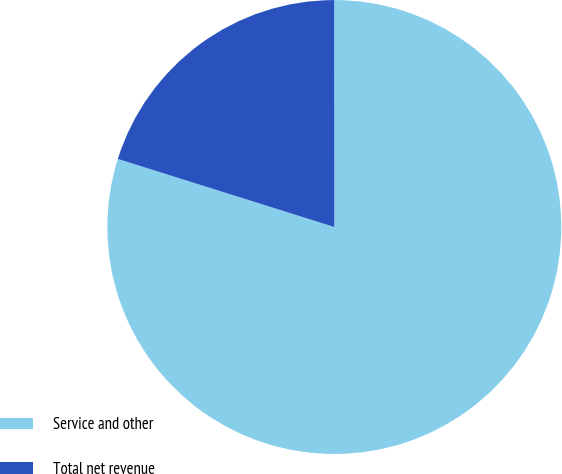Convert chart. <chart><loc_0><loc_0><loc_500><loc_500><pie_chart><fcel>Service and other<fcel>Total net revenue<nl><fcel>79.86%<fcel>20.14%<nl></chart> 